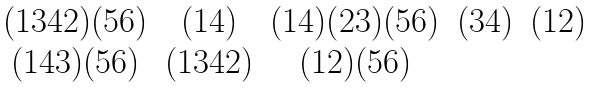<formula> <loc_0><loc_0><loc_500><loc_500>\begin{matrix} ( 1 3 4 2 ) ( 5 6 ) & ( 1 4 ) & ( 1 4 ) ( 2 3 ) ( 5 6 ) & ( 3 4 ) & ( 1 2 ) \\ ( 1 4 3 ) ( 5 6 ) & ( 1 3 4 2 ) & ( 1 2 ) ( 5 6 ) & & \end{matrix}</formula> 